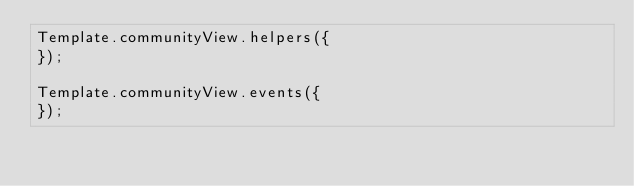Convert code to text. <code><loc_0><loc_0><loc_500><loc_500><_JavaScript_>Template.communityView.helpers({
});

Template.communityView.events({
});</code> 